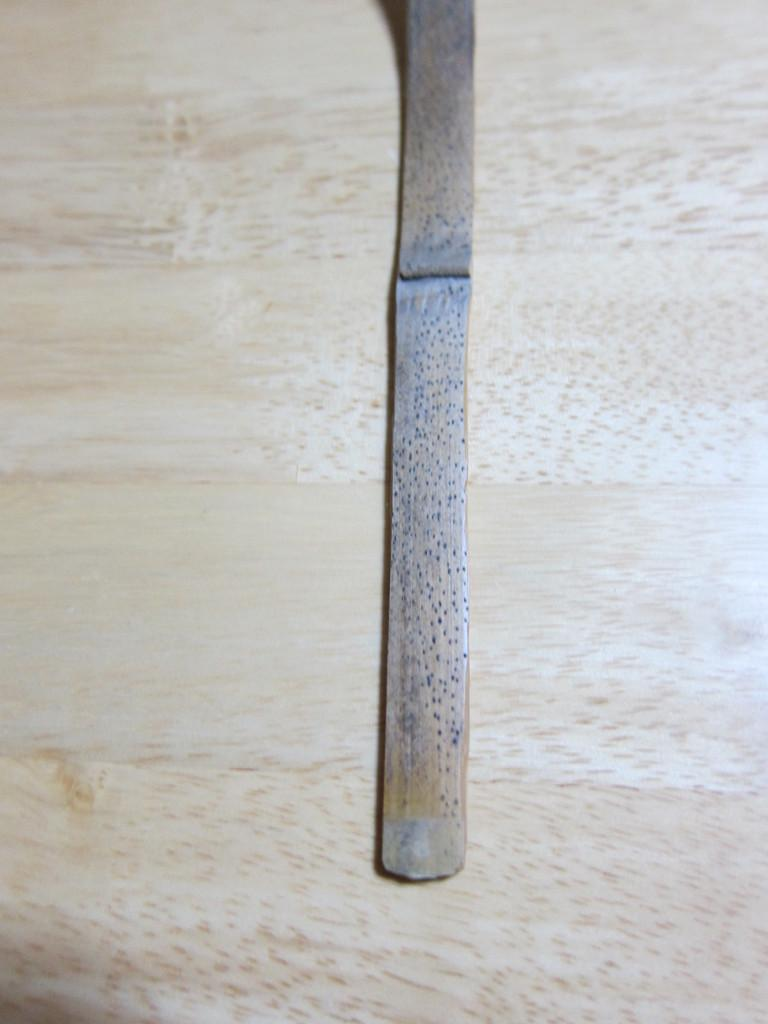What object is made of wood and present in the image? There is a wooden stick in the image. Where is the wooden stick located? The wooden stick is on a wooden table. What advice does the frog give to the wooden stick in the image? There is no frog present in the image, so it cannot give any advice to the wooden stick. 